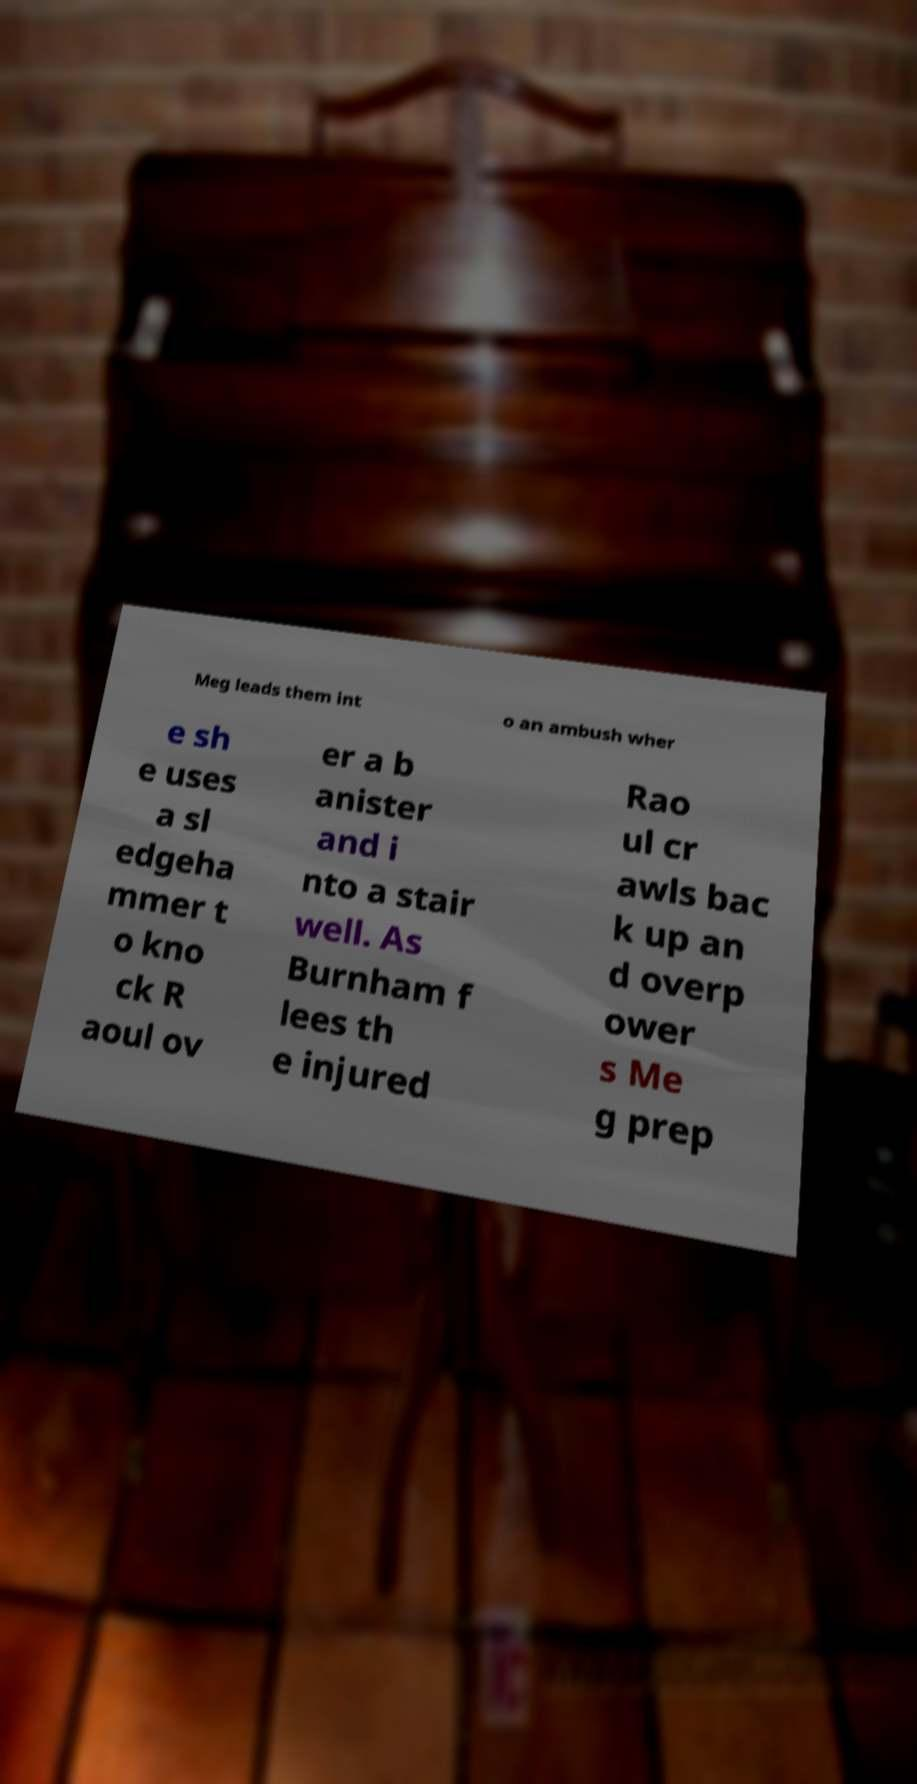What messages or text are displayed in this image? I need them in a readable, typed format. Meg leads them int o an ambush wher e sh e uses a sl edgeha mmer t o kno ck R aoul ov er a b anister and i nto a stair well. As Burnham f lees th e injured Rao ul cr awls bac k up an d overp ower s Me g prep 